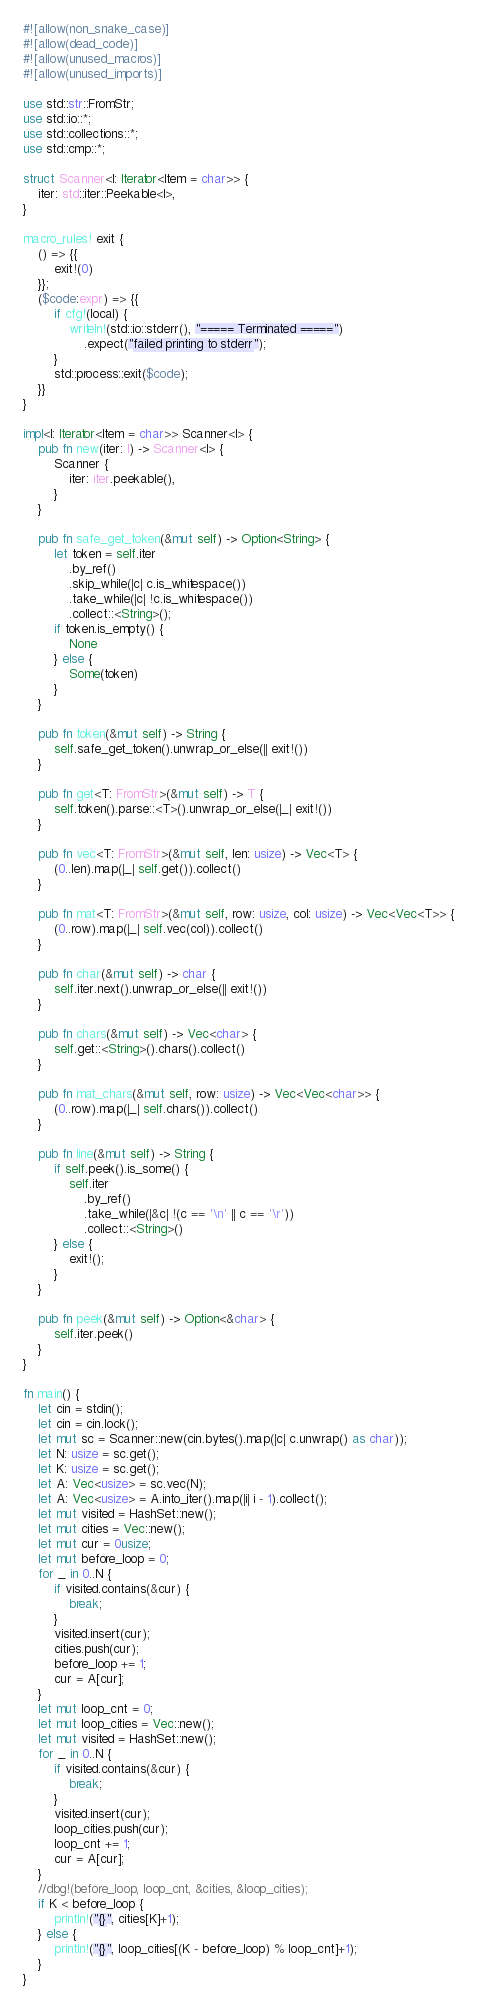<code> <loc_0><loc_0><loc_500><loc_500><_Rust_>#![allow(non_snake_case)]
#![allow(dead_code)]
#![allow(unused_macros)]
#![allow(unused_imports)]

use std::str::FromStr;
use std::io::*;
use std::collections::*;
use std::cmp::*;

struct Scanner<I: Iterator<Item = char>> {
    iter: std::iter::Peekable<I>,
}

macro_rules! exit {
    () => {{
        exit!(0)
    }};
    ($code:expr) => {{
        if cfg!(local) {
            writeln!(std::io::stderr(), "===== Terminated =====")
                .expect("failed printing to stderr");
        }
        std::process::exit($code);
    }}
}

impl<I: Iterator<Item = char>> Scanner<I> {
    pub fn new(iter: I) -> Scanner<I> {
        Scanner {
            iter: iter.peekable(),
        }
    }

    pub fn safe_get_token(&mut self) -> Option<String> {
        let token = self.iter
            .by_ref()
            .skip_while(|c| c.is_whitespace())
            .take_while(|c| !c.is_whitespace())
            .collect::<String>();
        if token.is_empty() {
            None
        } else {
            Some(token)
        }
    }

    pub fn token(&mut self) -> String {
        self.safe_get_token().unwrap_or_else(|| exit!())
    }

    pub fn get<T: FromStr>(&mut self) -> T {
        self.token().parse::<T>().unwrap_or_else(|_| exit!())
    }

    pub fn vec<T: FromStr>(&mut self, len: usize) -> Vec<T> {
        (0..len).map(|_| self.get()).collect()
    }

    pub fn mat<T: FromStr>(&mut self, row: usize, col: usize) -> Vec<Vec<T>> {
        (0..row).map(|_| self.vec(col)).collect()
    }

    pub fn char(&mut self) -> char {
        self.iter.next().unwrap_or_else(|| exit!())
    }

    pub fn chars(&mut self) -> Vec<char> {
        self.get::<String>().chars().collect()
    }

    pub fn mat_chars(&mut self, row: usize) -> Vec<Vec<char>> {
        (0..row).map(|_| self.chars()).collect()
    }

    pub fn line(&mut self) -> String {
        if self.peek().is_some() {
            self.iter
                .by_ref()
                .take_while(|&c| !(c == '\n' || c == '\r'))
                .collect::<String>()
        } else {
            exit!();
        }
    }

    pub fn peek(&mut self) -> Option<&char> {
        self.iter.peek()
    }
}

fn main() {
    let cin = stdin();
    let cin = cin.lock();
    let mut sc = Scanner::new(cin.bytes().map(|c| c.unwrap() as char));
    let N: usize = sc.get();
    let K: usize = sc.get();
    let A: Vec<usize> = sc.vec(N);
    let A: Vec<usize> = A.into_iter().map(|i| i - 1).collect();
    let mut visited = HashSet::new();
    let mut cities = Vec::new();
    let mut cur = 0usize;
    let mut before_loop = 0;
    for _ in 0..N {
        if visited.contains(&cur) {
            break;
        }
        visited.insert(cur);
        cities.push(cur);
        before_loop += 1;
        cur = A[cur];
    }
    let mut loop_cnt = 0;
    let mut loop_cities = Vec::new();
    let mut visited = HashSet::new();
    for _ in 0..N {
        if visited.contains(&cur) {
            break;
        }
        visited.insert(cur);
        loop_cities.push(cur);
        loop_cnt += 1;
        cur = A[cur];
    }
    //dbg!(before_loop, loop_cnt, &cities, &loop_cities);
    if K < before_loop {
        println!("{}", cities[K]+1);
    } else {
        println!("{}", loop_cities[(K - before_loop) % loop_cnt]+1);
    }
}
</code> 